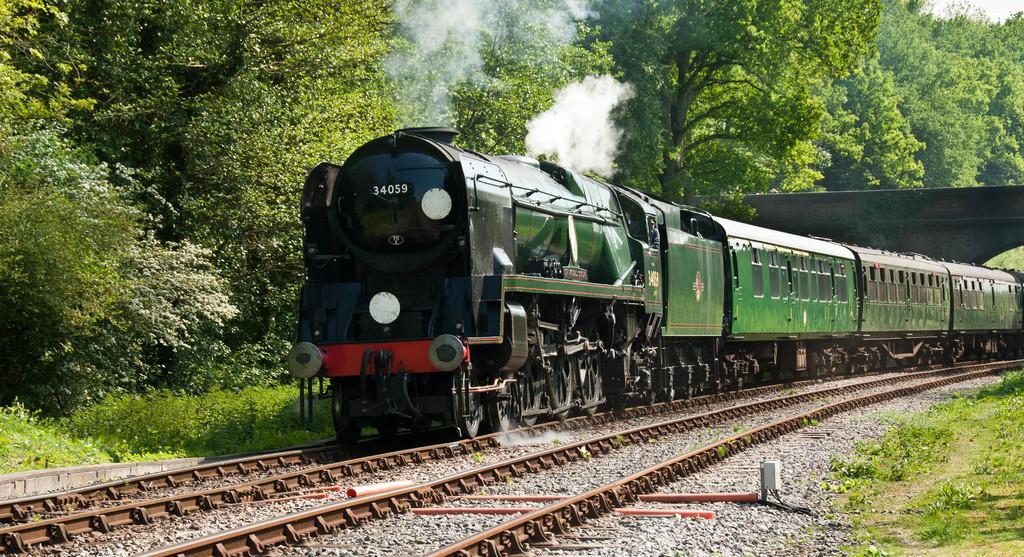What is the main subject of the image? The main subject of the image is a train. Where is the train located in the image? The train is on a railway track. What other structures can be seen in the image? There is a bridge visible in the image. What type of vegetation is present in the image? There are trees and plants in the image. What type of vacation is being requested by the train in the image? The image does not depict a train requesting a vacation; it simply shows a train on a railway track. 